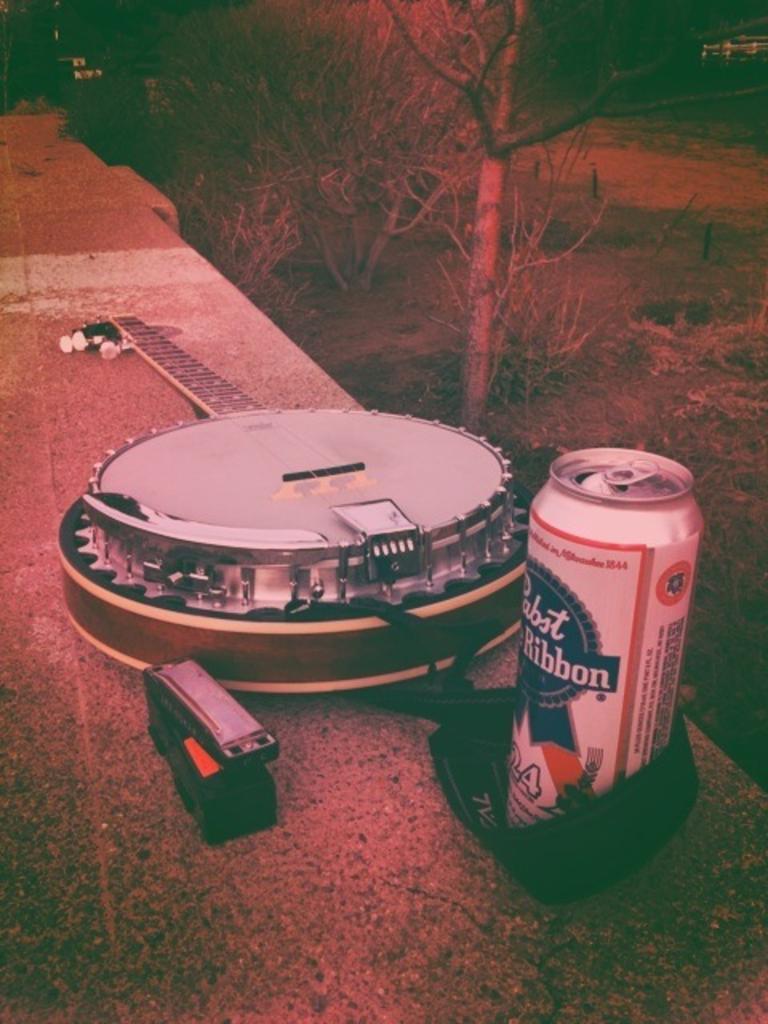What number is on the front of the beer can?
Ensure brevity in your answer.  24. 